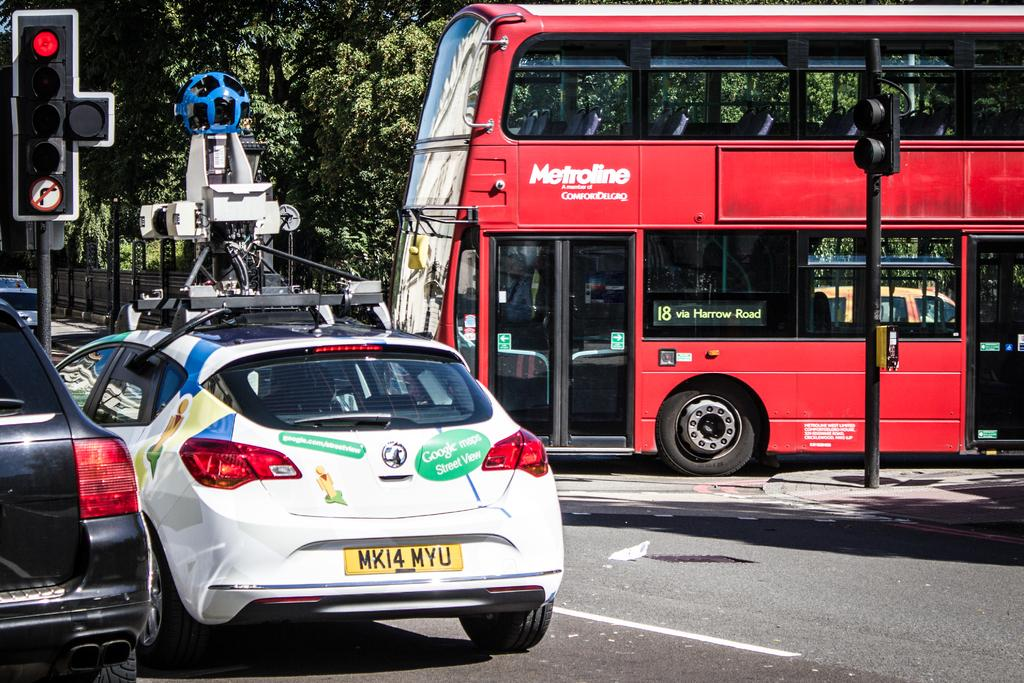What type of vehicles can be seen on the road in the image? There are cars on the road in the image. Is there any other type of vehicle visible in the image? Yes, there is a bus on the right side of the road in the image. What can be seen on either side of the road in the image? There are traffic light poles on either side of the road in the image. What is visible in the background of the image? Trees are present in the background of the image. What committee is responsible for the arithmetic in the image? There is no committee or arithmetic present in the image; it features cars, a bus, traffic light poles, and trees. 